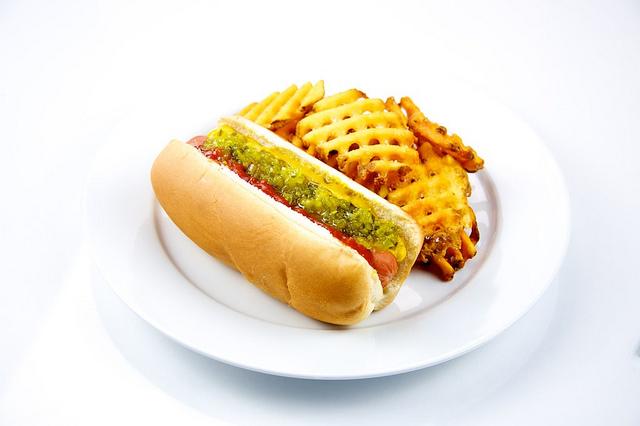Is the food eaten?
Be succinct. No. Is the food healthy?
Keep it brief. No. Is there mustard on the hot dog?
Answer briefly. Yes. Where do these items grow?
Short answer required. Ground. Is there barbecue sauce?
Write a very short answer. No. Do the potatoes on the plate have ridges?
Short answer required. Yes. What type of plate is it on?
Answer briefly. Glass. What are the yellow items?
Write a very short answer. Fries. 